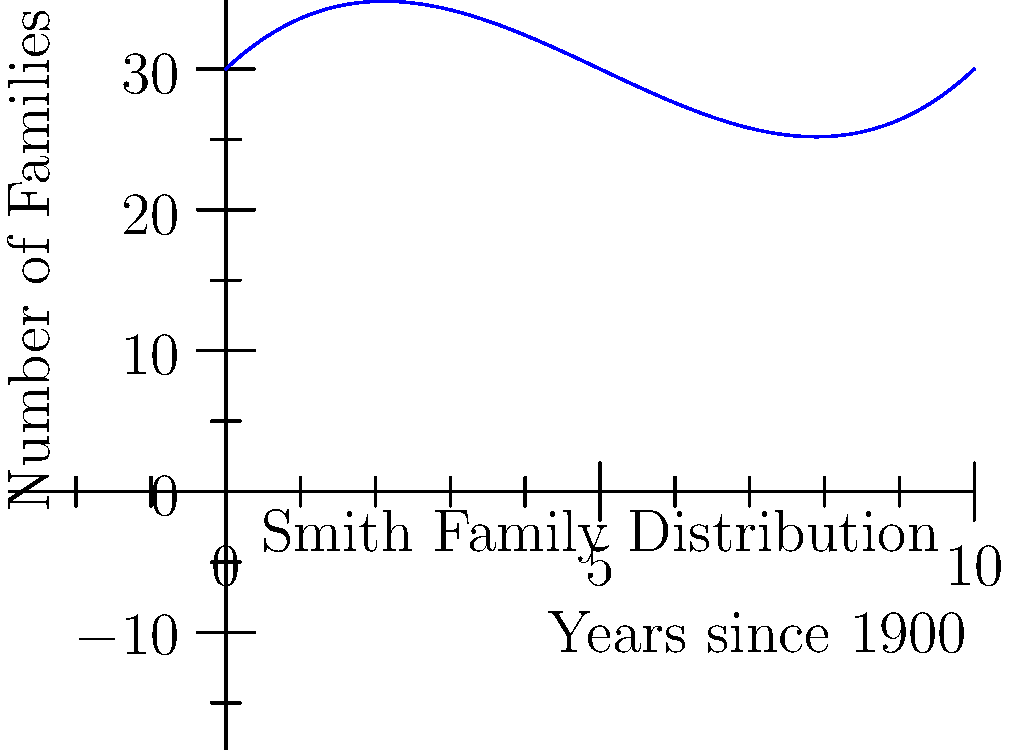The graph above represents the distribution of the Smith family surname over time. If the x-axis represents years since 1900 and the y-axis represents the number of families, what is the approximate rate of change in the number of Smith families between the years 1905 and 1910? To find the rate of change between 1905 and 1910, we need to:

1. Identify the points on the curve for 1905 (x = 5) and 1910 (x = 10).
2. Calculate the y-values for these points using the polynomial function:
   $f(x) = 0.1x^3 - 1.5x^2 + 5x + 30$
3. For 1905 (x = 5):
   $f(5) = 0.1(5^3) - 1.5(5^2) + 5(5) + 30 = 12.5 - 37.5 + 25 + 30 = 30$
4. For 1910 (x = 10):
   $f(10) = 0.1(10^3) - 1.5(10^2) + 5(10) + 30 = 100 - 150 + 50 + 30 = 30$
5. Calculate the rate of change:
   Rate of change = $\frac{\text{Change in y}}{\text{Change in x}} = \frac{30 - 30}{10 - 5} = \frac{0}{5} = 0$

Therefore, the approximate rate of change in the number of Smith families between 1905 and 1910 is 0 families per year.
Answer: 0 families per year 